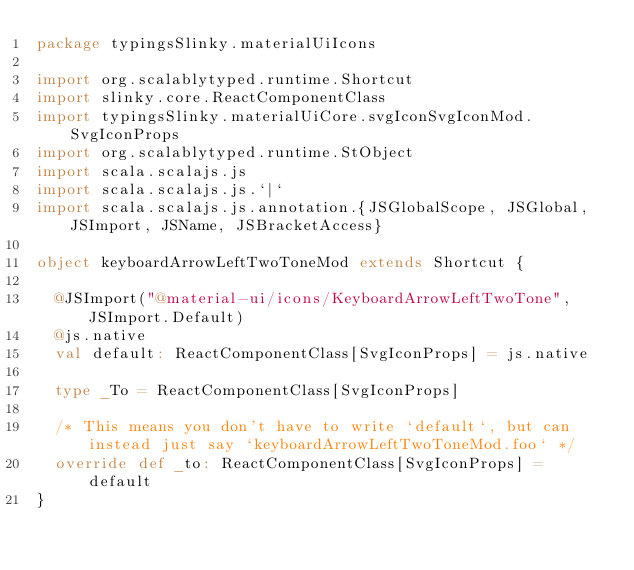<code> <loc_0><loc_0><loc_500><loc_500><_Scala_>package typingsSlinky.materialUiIcons

import org.scalablytyped.runtime.Shortcut
import slinky.core.ReactComponentClass
import typingsSlinky.materialUiCore.svgIconSvgIconMod.SvgIconProps
import org.scalablytyped.runtime.StObject
import scala.scalajs.js
import scala.scalajs.js.`|`
import scala.scalajs.js.annotation.{JSGlobalScope, JSGlobal, JSImport, JSName, JSBracketAccess}

object keyboardArrowLeftTwoToneMod extends Shortcut {
  
  @JSImport("@material-ui/icons/KeyboardArrowLeftTwoTone", JSImport.Default)
  @js.native
  val default: ReactComponentClass[SvgIconProps] = js.native
  
  type _To = ReactComponentClass[SvgIconProps]
  
  /* This means you don't have to write `default`, but can instead just say `keyboardArrowLeftTwoToneMod.foo` */
  override def _to: ReactComponentClass[SvgIconProps] = default
}
</code> 